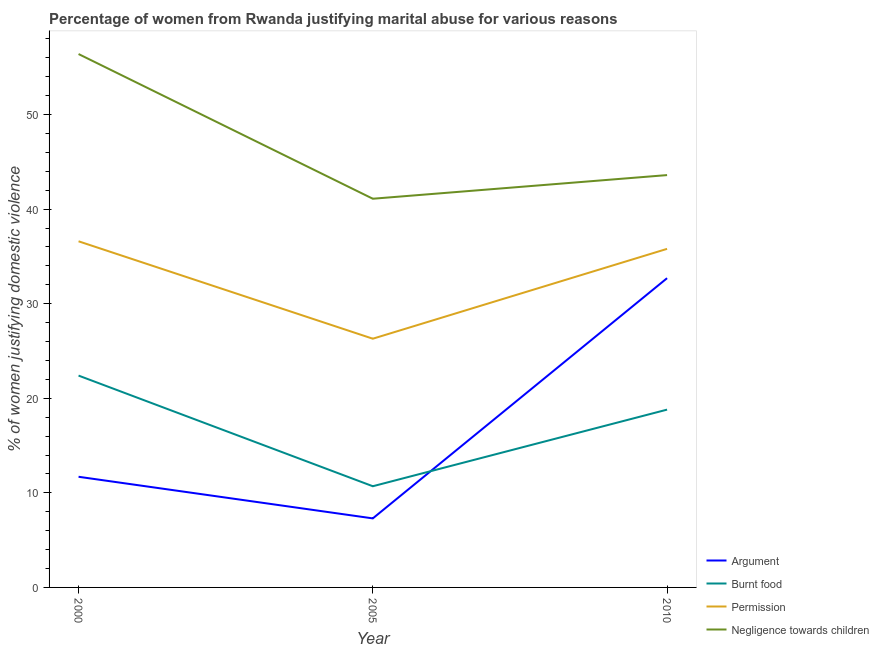How many different coloured lines are there?
Provide a short and direct response. 4. What is the percentage of women justifying abuse in the case of an argument in 2000?
Give a very brief answer. 11.7. Across all years, what is the maximum percentage of women justifying abuse in the case of an argument?
Offer a very short reply. 32.7. In which year was the percentage of women justifying abuse for burning food maximum?
Ensure brevity in your answer.  2000. In which year was the percentage of women justifying abuse in the case of an argument minimum?
Your answer should be very brief. 2005. What is the total percentage of women justifying abuse for going without permission in the graph?
Make the answer very short. 98.7. What is the difference between the percentage of women justifying abuse for going without permission in 2000 and that in 2010?
Give a very brief answer. 0.8. What is the difference between the percentage of women justifying abuse in the case of an argument in 2000 and the percentage of women justifying abuse for burning food in 2005?
Your response must be concise. 1. What is the average percentage of women justifying abuse for going without permission per year?
Give a very brief answer. 32.9. In the year 2000, what is the difference between the percentage of women justifying abuse in the case of an argument and percentage of women justifying abuse for showing negligence towards children?
Provide a succinct answer. -44.7. In how many years, is the percentage of women justifying abuse for burning food greater than 44 %?
Your answer should be very brief. 0. What is the ratio of the percentage of women justifying abuse for showing negligence towards children in 2000 to that in 2005?
Provide a short and direct response. 1.37. Is the difference between the percentage of women justifying abuse for showing negligence towards children in 2000 and 2005 greater than the difference between the percentage of women justifying abuse for burning food in 2000 and 2005?
Provide a succinct answer. Yes. What is the difference between the highest and the second highest percentage of women justifying abuse for showing negligence towards children?
Offer a terse response. 12.8. What is the difference between the highest and the lowest percentage of women justifying abuse in the case of an argument?
Your answer should be very brief. 25.4. In how many years, is the percentage of women justifying abuse for going without permission greater than the average percentage of women justifying abuse for going without permission taken over all years?
Give a very brief answer. 2. Is the sum of the percentage of women justifying abuse for burning food in 2005 and 2010 greater than the maximum percentage of women justifying abuse in the case of an argument across all years?
Your answer should be compact. No. Is it the case that in every year, the sum of the percentage of women justifying abuse in the case of an argument and percentage of women justifying abuse for burning food is greater than the percentage of women justifying abuse for going without permission?
Provide a short and direct response. No. Is the percentage of women justifying abuse in the case of an argument strictly greater than the percentage of women justifying abuse for showing negligence towards children over the years?
Provide a succinct answer. No. How many lines are there?
Your answer should be very brief. 4. What is the difference between two consecutive major ticks on the Y-axis?
Provide a short and direct response. 10. Are the values on the major ticks of Y-axis written in scientific E-notation?
Your answer should be compact. No. Does the graph contain any zero values?
Give a very brief answer. No. Does the graph contain grids?
Keep it short and to the point. No. How are the legend labels stacked?
Your response must be concise. Vertical. What is the title of the graph?
Your answer should be very brief. Percentage of women from Rwanda justifying marital abuse for various reasons. What is the label or title of the X-axis?
Keep it short and to the point. Year. What is the label or title of the Y-axis?
Keep it short and to the point. % of women justifying domestic violence. What is the % of women justifying domestic violence in Burnt food in 2000?
Offer a terse response. 22.4. What is the % of women justifying domestic violence in Permission in 2000?
Your answer should be very brief. 36.6. What is the % of women justifying domestic violence in Negligence towards children in 2000?
Your answer should be very brief. 56.4. What is the % of women justifying domestic violence in Argument in 2005?
Provide a short and direct response. 7.3. What is the % of women justifying domestic violence of Permission in 2005?
Make the answer very short. 26.3. What is the % of women justifying domestic violence of Negligence towards children in 2005?
Offer a very short reply. 41.1. What is the % of women justifying domestic violence of Argument in 2010?
Make the answer very short. 32.7. What is the % of women justifying domestic violence of Permission in 2010?
Offer a terse response. 35.8. What is the % of women justifying domestic violence in Negligence towards children in 2010?
Provide a succinct answer. 43.6. Across all years, what is the maximum % of women justifying domestic violence in Argument?
Keep it short and to the point. 32.7. Across all years, what is the maximum % of women justifying domestic violence in Burnt food?
Offer a very short reply. 22.4. Across all years, what is the maximum % of women justifying domestic violence in Permission?
Your answer should be very brief. 36.6. Across all years, what is the maximum % of women justifying domestic violence of Negligence towards children?
Provide a succinct answer. 56.4. Across all years, what is the minimum % of women justifying domestic violence in Argument?
Provide a short and direct response. 7.3. Across all years, what is the minimum % of women justifying domestic violence in Permission?
Your response must be concise. 26.3. Across all years, what is the minimum % of women justifying domestic violence of Negligence towards children?
Give a very brief answer. 41.1. What is the total % of women justifying domestic violence in Argument in the graph?
Give a very brief answer. 51.7. What is the total % of women justifying domestic violence in Burnt food in the graph?
Give a very brief answer. 51.9. What is the total % of women justifying domestic violence of Permission in the graph?
Make the answer very short. 98.7. What is the total % of women justifying domestic violence of Negligence towards children in the graph?
Your answer should be very brief. 141.1. What is the difference between the % of women justifying domestic violence of Argument in 2000 and that in 2005?
Provide a succinct answer. 4.4. What is the difference between the % of women justifying domestic violence of Burnt food in 2000 and that in 2005?
Offer a terse response. 11.7. What is the difference between the % of women justifying domestic violence in Permission in 2000 and that in 2005?
Offer a terse response. 10.3. What is the difference between the % of women justifying domestic violence of Negligence towards children in 2000 and that in 2005?
Your answer should be compact. 15.3. What is the difference between the % of women justifying domestic violence of Argument in 2000 and that in 2010?
Ensure brevity in your answer.  -21. What is the difference between the % of women justifying domestic violence of Argument in 2005 and that in 2010?
Offer a terse response. -25.4. What is the difference between the % of women justifying domestic violence of Burnt food in 2005 and that in 2010?
Provide a short and direct response. -8.1. What is the difference between the % of women justifying domestic violence in Permission in 2005 and that in 2010?
Keep it short and to the point. -9.5. What is the difference between the % of women justifying domestic violence of Argument in 2000 and the % of women justifying domestic violence of Burnt food in 2005?
Keep it short and to the point. 1. What is the difference between the % of women justifying domestic violence of Argument in 2000 and the % of women justifying domestic violence of Permission in 2005?
Your response must be concise. -14.6. What is the difference between the % of women justifying domestic violence of Argument in 2000 and the % of women justifying domestic violence of Negligence towards children in 2005?
Offer a terse response. -29.4. What is the difference between the % of women justifying domestic violence of Burnt food in 2000 and the % of women justifying domestic violence of Permission in 2005?
Offer a terse response. -3.9. What is the difference between the % of women justifying domestic violence in Burnt food in 2000 and the % of women justifying domestic violence in Negligence towards children in 2005?
Give a very brief answer. -18.7. What is the difference between the % of women justifying domestic violence in Argument in 2000 and the % of women justifying domestic violence in Burnt food in 2010?
Make the answer very short. -7.1. What is the difference between the % of women justifying domestic violence of Argument in 2000 and the % of women justifying domestic violence of Permission in 2010?
Offer a very short reply. -24.1. What is the difference between the % of women justifying domestic violence of Argument in 2000 and the % of women justifying domestic violence of Negligence towards children in 2010?
Make the answer very short. -31.9. What is the difference between the % of women justifying domestic violence of Burnt food in 2000 and the % of women justifying domestic violence of Permission in 2010?
Your answer should be very brief. -13.4. What is the difference between the % of women justifying domestic violence in Burnt food in 2000 and the % of women justifying domestic violence in Negligence towards children in 2010?
Ensure brevity in your answer.  -21.2. What is the difference between the % of women justifying domestic violence of Argument in 2005 and the % of women justifying domestic violence of Burnt food in 2010?
Keep it short and to the point. -11.5. What is the difference between the % of women justifying domestic violence in Argument in 2005 and the % of women justifying domestic violence in Permission in 2010?
Your response must be concise. -28.5. What is the difference between the % of women justifying domestic violence of Argument in 2005 and the % of women justifying domestic violence of Negligence towards children in 2010?
Your answer should be very brief. -36.3. What is the difference between the % of women justifying domestic violence in Burnt food in 2005 and the % of women justifying domestic violence in Permission in 2010?
Ensure brevity in your answer.  -25.1. What is the difference between the % of women justifying domestic violence in Burnt food in 2005 and the % of women justifying domestic violence in Negligence towards children in 2010?
Provide a succinct answer. -32.9. What is the difference between the % of women justifying domestic violence in Permission in 2005 and the % of women justifying domestic violence in Negligence towards children in 2010?
Ensure brevity in your answer.  -17.3. What is the average % of women justifying domestic violence in Argument per year?
Provide a succinct answer. 17.23. What is the average % of women justifying domestic violence of Permission per year?
Offer a very short reply. 32.9. What is the average % of women justifying domestic violence in Negligence towards children per year?
Give a very brief answer. 47.03. In the year 2000, what is the difference between the % of women justifying domestic violence in Argument and % of women justifying domestic violence in Permission?
Your response must be concise. -24.9. In the year 2000, what is the difference between the % of women justifying domestic violence of Argument and % of women justifying domestic violence of Negligence towards children?
Your answer should be very brief. -44.7. In the year 2000, what is the difference between the % of women justifying domestic violence of Burnt food and % of women justifying domestic violence of Permission?
Give a very brief answer. -14.2. In the year 2000, what is the difference between the % of women justifying domestic violence of Burnt food and % of women justifying domestic violence of Negligence towards children?
Your answer should be compact. -34. In the year 2000, what is the difference between the % of women justifying domestic violence of Permission and % of women justifying domestic violence of Negligence towards children?
Keep it short and to the point. -19.8. In the year 2005, what is the difference between the % of women justifying domestic violence in Argument and % of women justifying domestic violence in Permission?
Your response must be concise. -19. In the year 2005, what is the difference between the % of women justifying domestic violence of Argument and % of women justifying domestic violence of Negligence towards children?
Make the answer very short. -33.8. In the year 2005, what is the difference between the % of women justifying domestic violence in Burnt food and % of women justifying domestic violence in Permission?
Make the answer very short. -15.6. In the year 2005, what is the difference between the % of women justifying domestic violence in Burnt food and % of women justifying domestic violence in Negligence towards children?
Make the answer very short. -30.4. In the year 2005, what is the difference between the % of women justifying domestic violence of Permission and % of women justifying domestic violence of Negligence towards children?
Keep it short and to the point. -14.8. In the year 2010, what is the difference between the % of women justifying domestic violence of Argument and % of women justifying domestic violence of Burnt food?
Offer a very short reply. 13.9. In the year 2010, what is the difference between the % of women justifying domestic violence in Argument and % of women justifying domestic violence in Permission?
Offer a terse response. -3.1. In the year 2010, what is the difference between the % of women justifying domestic violence of Burnt food and % of women justifying domestic violence of Permission?
Offer a terse response. -17. In the year 2010, what is the difference between the % of women justifying domestic violence in Burnt food and % of women justifying domestic violence in Negligence towards children?
Offer a terse response. -24.8. In the year 2010, what is the difference between the % of women justifying domestic violence of Permission and % of women justifying domestic violence of Negligence towards children?
Offer a very short reply. -7.8. What is the ratio of the % of women justifying domestic violence in Argument in 2000 to that in 2005?
Your response must be concise. 1.6. What is the ratio of the % of women justifying domestic violence in Burnt food in 2000 to that in 2005?
Give a very brief answer. 2.09. What is the ratio of the % of women justifying domestic violence in Permission in 2000 to that in 2005?
Make the answer very short. 1.39. What is the ratio of the % of women justifying domestic violence in Negligence towards children in 2000 to that in 2005?
Make the answer very short. 1.37. What is the ratio of the % of women justifying domestic violence in Argument in 2000 to that in 2010?
Keep it short and to the point. 0.36. What is the ratio of the % of women justifying domestic violence of Burnt food in 2000 to that in 2010?
Your answer should be very brief. 1.19. What is the ratio of the % of women justifying domestic violence in Permission in 2000 to that in 2010?
Keep it short and to the point. 1.02. What is the ratio of the % of women justifying domestic violence of Negligence towards children in 2000 to that in 2010?
Offer a very short reply. 1.29. What is the ratio of the % of women justifying domestic violence in Argument in 2005 to that in 2010?
Offer a terse response. 0.22. What is the ratio of the % of women justifying domestic violence in Burnt food in 2005 to that in 2010?
Offer a terse response. 0.57. What is the ratio of the % of women justifying domestic violence in Permission in 2005 to that in 2010?
Offer a very short reply. 0.73. What is the ratio of the % of women justifying domestic violence in Negligence towards children in 2005 to that in 2010?
Provide a succinct answer. 0.94. What is the difference between the highest and the second highest % of women justifying domestic violence in Argument?
Your answer should be compact. 21. What is the difference between the highest and the second highest % of women justifying domestic violence in Permission?
Ensure brevity in your answer.  0.8. What is the difference between the highest and the second highest % of women justifying domestic violence in Negligence towards children?
Provide a succinct answer. 12.8. What is the difference between the highest and the lowest % of women justifying domestic violence of Argument?
Offer a very short reply. 25.4. What is the difference between the highest and the lowest % of women justifying domestic violence in Burnt food?
Your answer should be very brief. 11.7. 